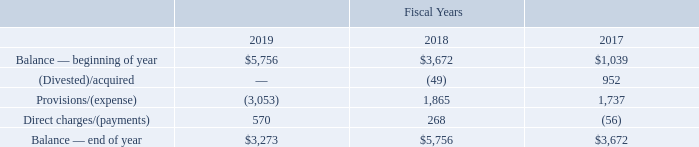16. PRODUCT WARRANTIES
We establish a product warranty liability at the time of revenue recognition. Product warranties generally have terms of 12 months and cover nonconformance with specifications and defects in material or workmanship. For sales to distributors, our warranty generally begins when the product is resold by the distributor. The liability is based on estimated costs to fulfill customer product warranty obligations and utilizes historical product failure rates. Should actual warranty obligations differ from estimates, revisions to the warranty liability may be required.
Product warranty liability activity is as follows (in thousands):
What was the (Divested)/acquired values in 2019, 2018 and 2017 respectively?
Answer scale should be: thousand. —, (49), 952. What was the Balance — beginning of year in 2018?
Answer scale should be: thousand. $3,672. What was the Balance — beginning of year in 2019?
Answer scale should be: thousand. $5,756. In which year was Balance — beginning of year less than 5,000 thousands? Locate and analyze balance — beginning of year in row 3
answer: 2018, 2017. What was the change in the Provisions/(expense) from 2017 to 2018?
Answer scale should be: thousand. 1,865 - 1,737
Answer: 128. What is the average Direct charges/(payments) for 2017-2019?
Answer scale should be: thousand. (570 + 268 - 56) / 3
Answer: 260.67. 